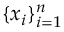Convert formula to latex. <formula><loc_0><loc_0><loc_500><loc_500>\{ x _ { i } \} _ { i = 1 } ^ { n }</formula> 